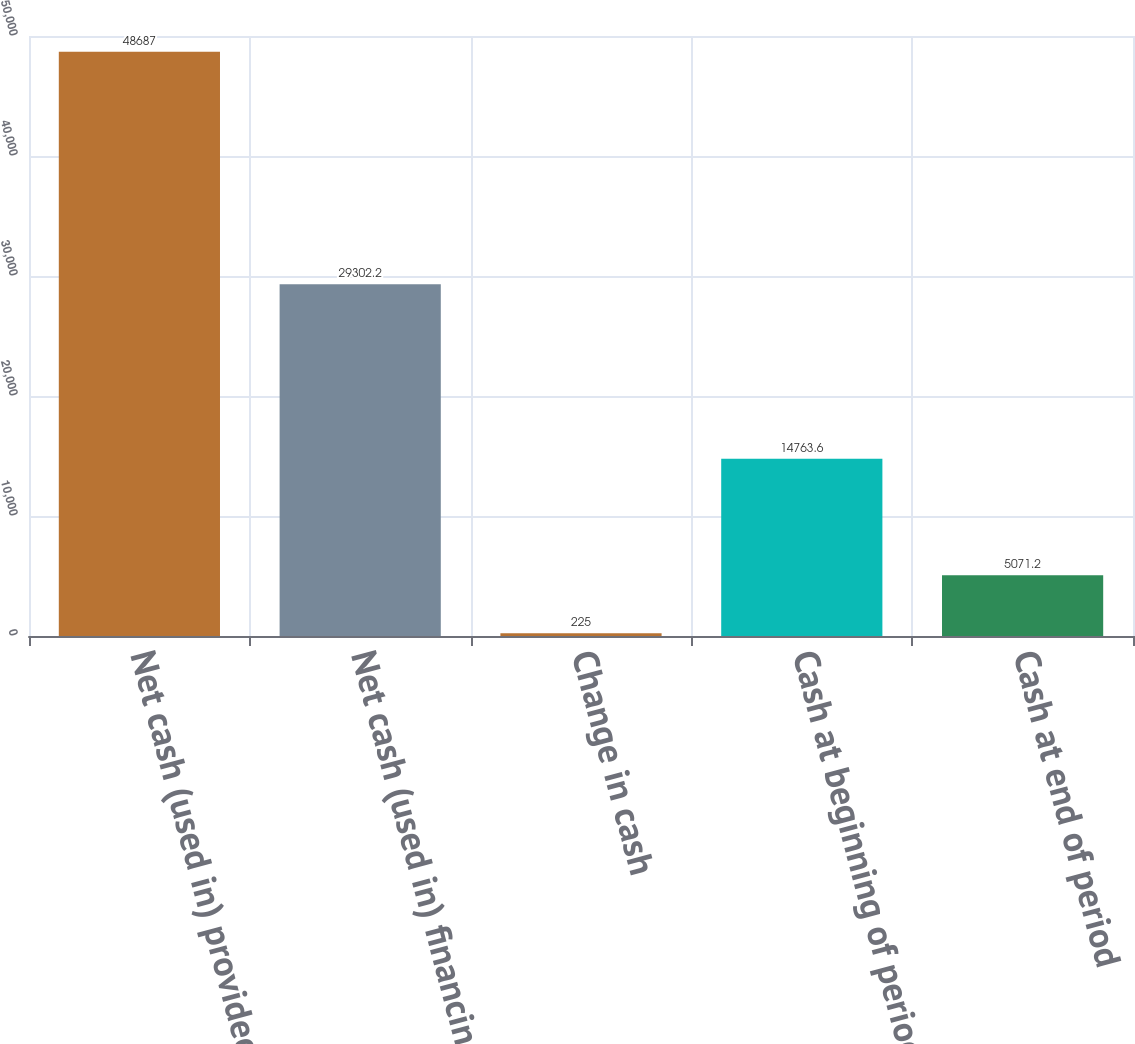Convert chart. <chart><loc_0><loc_0><loc_500><loc_500><bar_chart><fcel>Net cash (used in) provided by<fcel>Net cash (used in) financing<fcel>Change in cash<fcel>Cash at beginning of period<fcel>Cash at end of period<nl><fcel>48687<fcel>29302.2<fcel>225<fcel>14763.6<fcel>5071.2<nl></chart> 